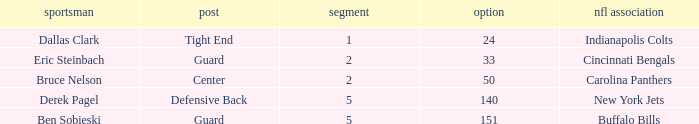During which round was a Hawkeyes player selected for the defensive back position? 5.0. Can you parse all the data within this table? {'header': ['sportsman', 'post', 'segment', 'option', 'nfl association'], 'rows': [['Dallas Clark', 'Tight End', '1', '24', 'Indianapolis Colts'], ['Eric Steinbach', 'Guard', '2', '33', 'Cincinnati Bengals'], ['Bruce Nelson', 'Center', '2', '50', 'Carolina Panthers'], ['Derek Pagel', 'Defensive Back', '5', '140', 'New York Jets'], ['Ben Sobieski', 'Guard', '5', '151', 'Buffalo Bills']]} 